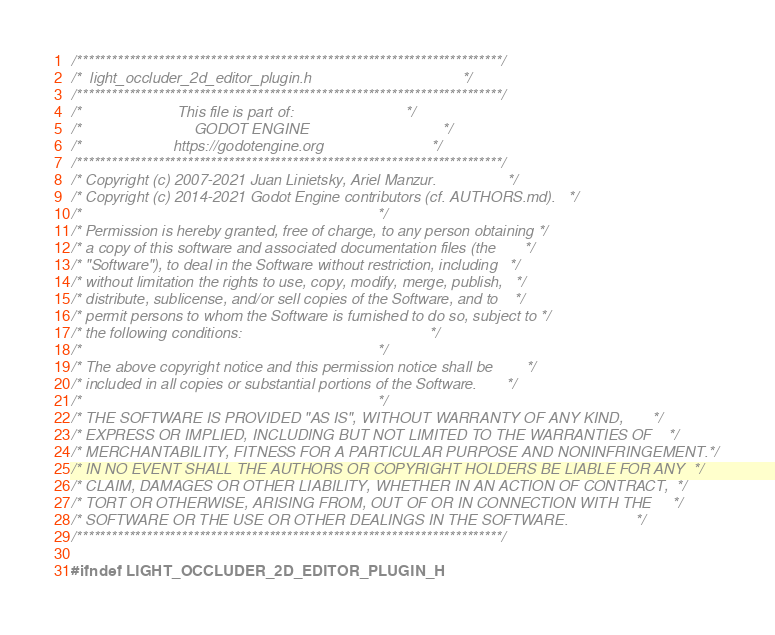<code> <loc_0><loc_0><loc_500><loc_500><_C_>/*************************************************************************/
/*  light_occluder_2d_editor_plugin.h                                    */
/*************************************************************************/
/*                       This file is part of:                           */
/*                           GODOT ENGINE                                */
/*                      https://godotengine.org                          */
/*************************************************************************/
/* Copyright (c) 2007-2021 Juan Linietsky, Ariel Manzur.                 */
/* Copyright (c) 2014-2021 Godot Engine contributors (cf. AUTHORS.md).   */
/*                                                                       */
/* Permission is hereby granted, free of charge, to any person obtaining */
/* a copy of this software and associated documentation files (the       */
/* "Software"), to deal in the Software without restriction, including   */
/* without limitation the rights to use, copy, modify, merge, publish,   */
/* distribute, sublicense, and/or sell copies of the Software, and to    */
/* permit persons to whom the Software is furnished to do so, subject to */
/* the following conditions:                                             */
/*                                                                       */
/* The above copyright notice and this permission notice shall be        */
/* included in all copies or substantial portions of the Software.       */
/*                                                                       */
/* THE SOFTWARE IS PROVIDED "AS IS", WITHOUT WARRANTY OF ANY KIND,       */
/* EXPRESS OR IMPLIED, INCLUDING BUT NOT LIMITED TO THE WARRANTIES OF    */
/* MERCHANTABILITY, FITNESS FOR A PARTICULAR PURPOSE AND NONINFRINGEMENT.*/
/* IN NO EVENT SHALL THE AUTHORS OR COPYRIGHT HOLDERS BE LIABLE FOR ANY  */
/* CLAIM, DAMAGES OR OTHER LIABILITY, WHETHER IN AN ACTION OF CONTRACT,  */
/* TORT OR OTHERWISE, ARISING FROM, OUT OF OR IN CONNECTION WITH THE     */
/* SOFTWARE OR THE USE OR OTHER DEALINGS IN THE SOFTWARE.                */
/*************************************************************************/

#ifndef LIGHT_OCCLUDER_2D_EDITOR_PLUGIN_H</code> 